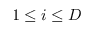<formula> <loc_0><loc_0><loc_500><loc_500>1 \leq i \leq D</formula> 